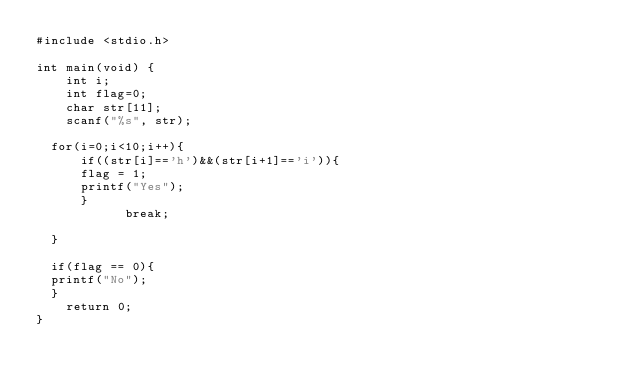Convert code to text. <code><loc_0><loc_0><loc_500><loc_500><_C_>#include <stdio.h>
 
int main(void) {
    int i;
    int flag=0;
    char str[11];
    scanf("%s", str);

	for(i=0;i<10;i++){
    	if((str[i]=='h')&&(str[i+1]=='i')){
    	flag = 1;
    	printf("Yes");
	   	}
	   	    	break;

	}

	if(flag == 0){
	printf("No");
	}
    return 0;
}</code> 